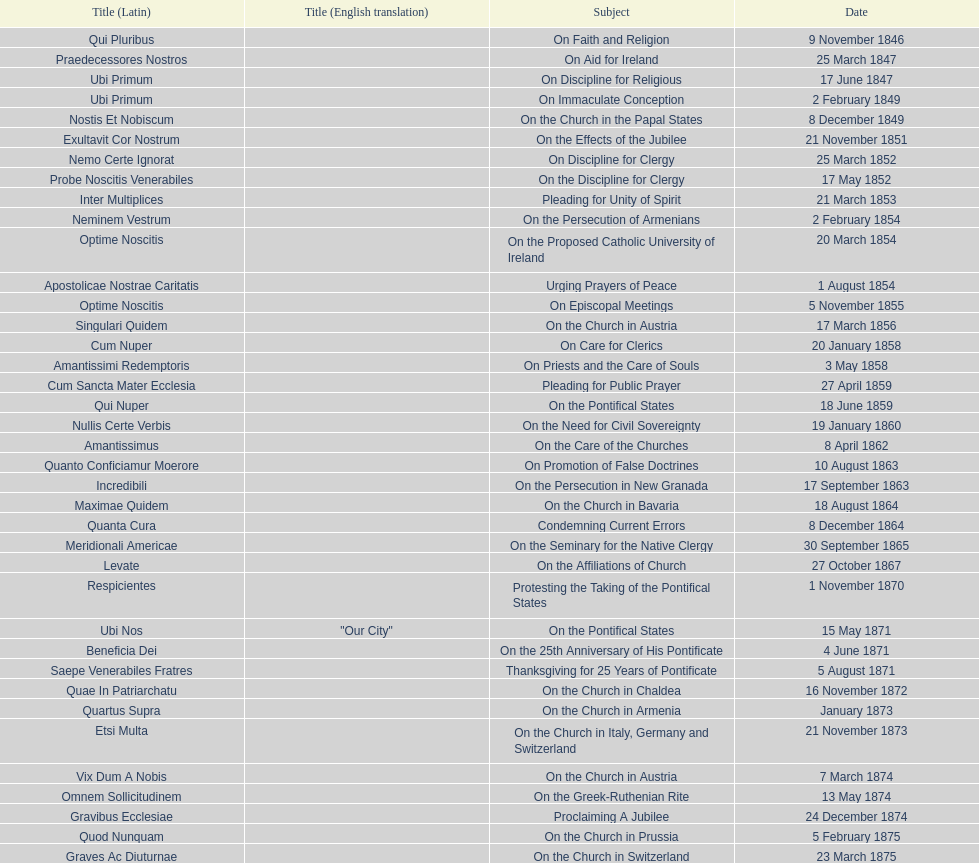Can you give me this table as a dict? {'header': ['Title (Latin)', 'Title (English translation)', 'Subject', 'Date'], 'rows': [['Qui Pluribus', '', 'On Faith and Religion', '9 November 1846'], ['Praedecessores Nostros', '', 'On Aid for Ireland', '25 March 1847'], ['Ubi Primum', '', 'On Discipline for Religious', '17 June 1847'], ['Ubi Primum', '', 'On Immaculate Conception', '2 February 1849'], ['Nostis Et Nobiscum', '', 'On the Church in the Papal States', '8 December 1849'], ['Exultavit Cor Nostrum', '', 'On the Effects of the Jubilee', '21 November 1851'], ['Nemo Certe Ignorat', '', 'On Discipline for Clergy', '25 March 1852'], ['Probe Noscitis Venerabiles', '', 'On the Discipline for Clergy', '17 May 1852'], ['Inter Multiplices', '', 'Pleading for Unity of Spirit', '21 March 1853'], ['Neminem Vestrum', '', 'On the Persecution of Armenians', '2 February 1854'], ['Optime Noscitis', '', 'On the Proposed Catholic University of Ireland', '20 March 1854'], ['Apostolicae Nostrae Caritatis', '', 'Urging Prayers of Peace', '1 August 1854'], ['Optime Noscitis', '', 'On Episcopal Meetings', '5 November 1855'], ['Singulari Quidem', '', 'On the Church in Austria', '17 March 1856'], ['Cum Nuper', '', 'On Care for Clerics', '20 January 1858'], ['Amantissimi Redemptoris', '', 'On Priests and the Care of Souls', '3 May 1858'], ['Cum Sancta Mater Ecclesia', '', 'Pleading for Public Prayer', '27 April 1859'], ['Qui Nuper', '', 'On the Pontifical States', '18 June 1859'], ['Nullis Certe Verbis', '', 'On the Need for Civil Sovereignty', '19 January 1860'], ['Amantissimus', '', 'On the Care of the Churches', '8 April 1862'], ['Quanto Conficiamur Moerore', '', 'On Promotion of False Doctrines', '10 August 1863'], ['Incredibili', '', 'On the Persecution in New Granada', '17 September 1863'], ['Maximae Quidem', '', 'On the Church in Bavaria', '18 August 1864'], ['Quanta Cura', '', 'Condemning Current Errors', '8 December 1864'], ['Meridionali Americae', '', 'On the Seminary for the Native Clergy', '30 September 1865'], ['Levate', '', 'On the Affiliations of Church', '27 October 1867'], ['Respicientes', '', 'Protesting the Taking of the Pontifical States', '1 November 1870'], ['Ubi Nos', '"Our City"', 'On the Pontifical States', '15 May 1871'], ['Beneficia Dei', '', 'On the 25th Anniversary of His Pontificate', '4 June 1871'], ['Saepe Venerabiles Fratres', '', 'Thanksgiving for 25 Years of Pontificate', '5 August 1871'], ['Quae In Patriarchatu', '', 'On the Church in Chaldea', '16 November 1872'], ['Quartus Supra', '', 'On the Church in Armenia', 'January 1873'], ['Etsi Multa', '', 'On the Church in Italy, Germany and Switzerland', '21 November 1873'], ['Vix Dum A Nobis', '', 'On the Church in Austria', '7 March 1874'], ['Omnem Sollicitudinem', '', 'On the Greek-Ruthenian Rite', '13 May 1874'], ['Gravibus Ecclesiae', '', 'Proclaiming A Jubilee', '24 December 1874'], ['Quod Nunquam', '', 'On the Church in Prussia', '5 February 1875'], ['Graves Ac Diuturnae', '', 'On the Church in Switzerland', '23 March 1875']]} How many subjects are there? 38. 